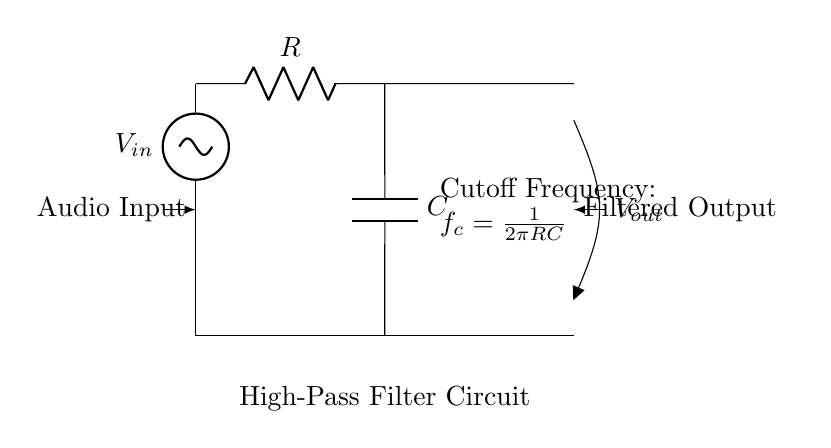What is the input voltage represented in the circuit? The input voltage is denoted as V_in in the circuit diagram, which clearly labels the voltage source connected at the top of the circuit.
Answer: V_in What components are present in this high-pass filter? The circuit consists of a resistor labeled R and a capacitor labeled C, which are crucial components for creating the high-pass filter functionality.
Answer: R, C What is the output voltage labeled in the diagram? The output voltage is labeled as V_out in the diagram, indicating where the filtered signal exits the circuit after passing through the components.
Answer: V_out What is the formula for the cutoff frequency shown in the circuit? The cutoff frequency is indicated in the circuit diagram as f_c = 1/(2πRC), which provides the relationship between the resistor, capacitor, and frequency.
Answer: f_c = 1/(2πRC) How does the circuit affect low-frequency signals? The high-pass filter design allows low-frequency signals to be attenuated or reduced, thus it is specifically meant to eliminate low-frequency noise from audio recordings.
Answer: Attenuates low frequencies What can be inferred about the signal flow in this circuit? The diagram has arrow indicators showing the direction of signal flow from the audio input through the high-pass filter to the filtered output, indicating a clear path for the audio signal.
Answer: From input to output What happens if the values of R or C are decreased? Decreasing R or C results in an increased cutoff frequency, which means that the filter will allow a wider range of higher frequencies to pass while continuing to block low frequencies.
Answer: Increases cutoff frequency 